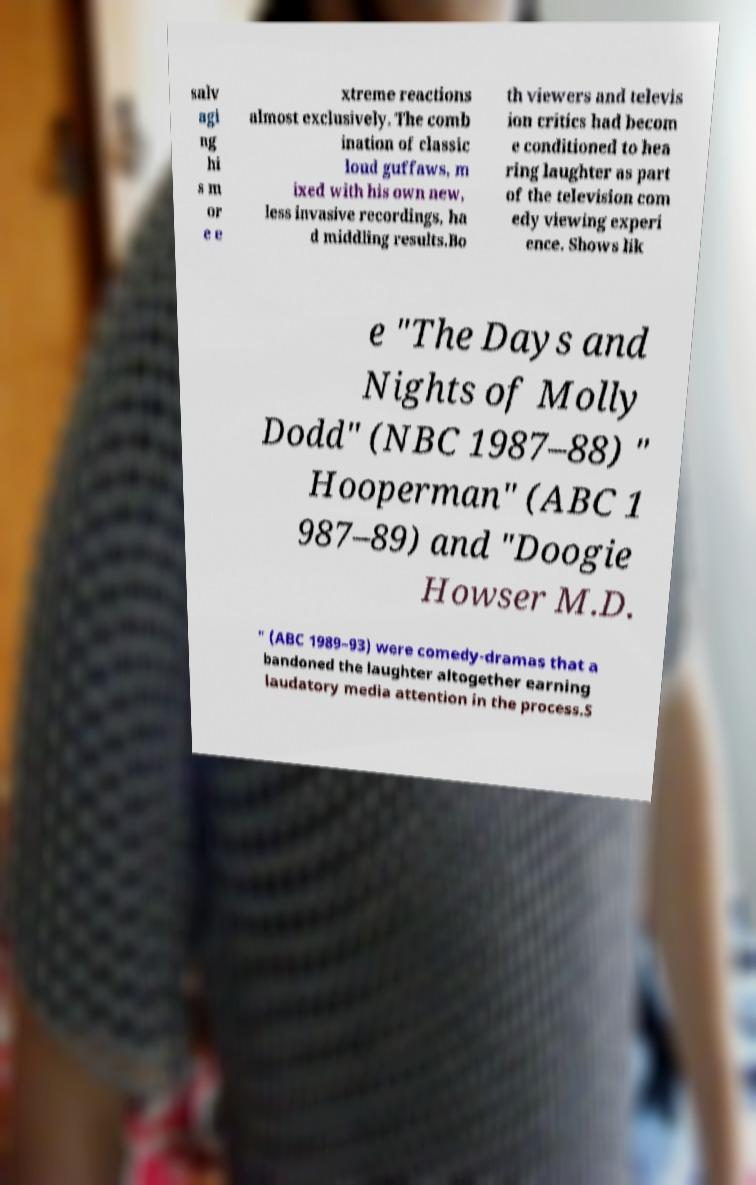Could you extract and type out the text from this image? salv agi ng hi s m or e e xtreme reactions almost exclusively. The comb ination of classic loud guffaws, m ixed with his own new, less invasive recordings, ha d middling results.Bo th viewers and televis ion critics had becom e conditioned to hea ring laughter as part of the television com edy viewing experi ence. Shows lik e "The Days and Nights of Molly Dodd" (NBC 1987–88) " Hooperman" (ABC 1 987–89) and "Doogie Howser M.D. " (ABC 1989–93) were comedy-dramas that a bandoned the laughter altogether earning laudatory media attention in the process.S 